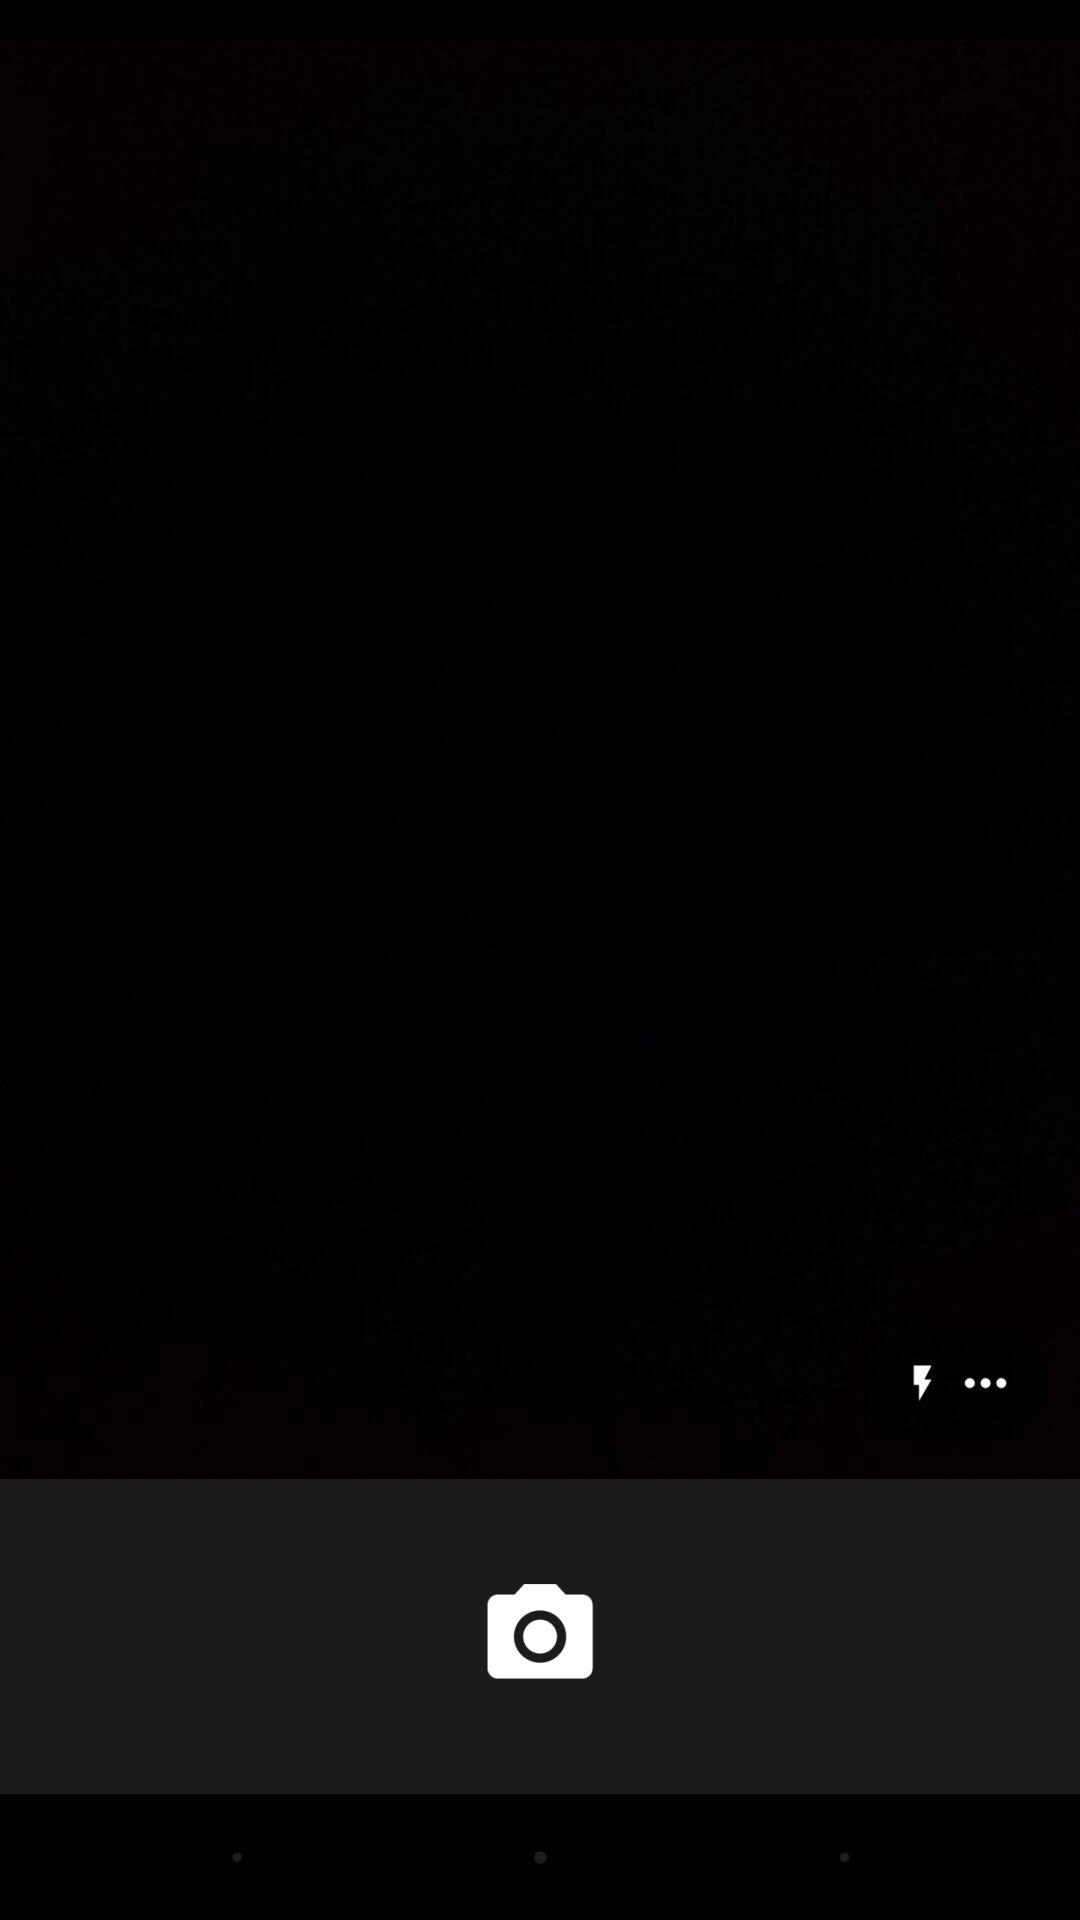How many more dots are there than lightning bolts?
Answer the question using a single word or phrase. 2 